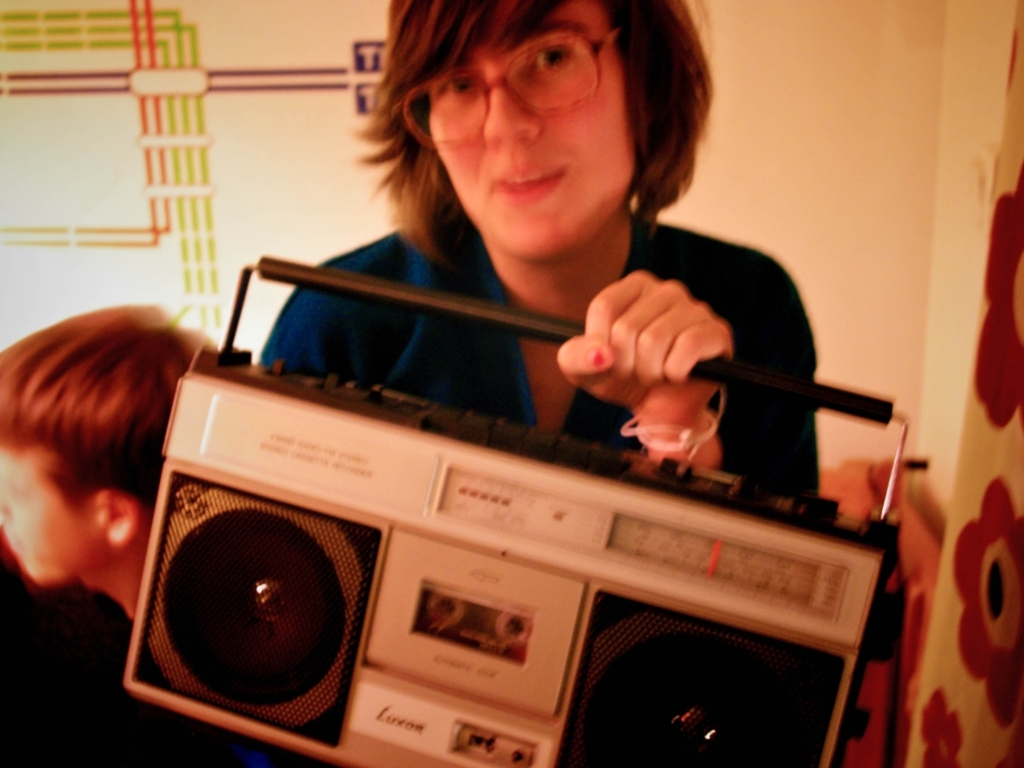What could be the reason for the person's interest in the cassette player? Given the inclusion of the cassette player, it could be that the person is a collector or enthusiast of vintage audio equipment, or they might simply enjoy the nostalgic aspect of using retro technology. Is there anything in the image that indicates when it was taken? The image lacks any definitive time indicators, but the style of the cassette player, along with the overall image quality, suggests it could be from a time when such devices were more commonly used, perhaps a few decades ago. 